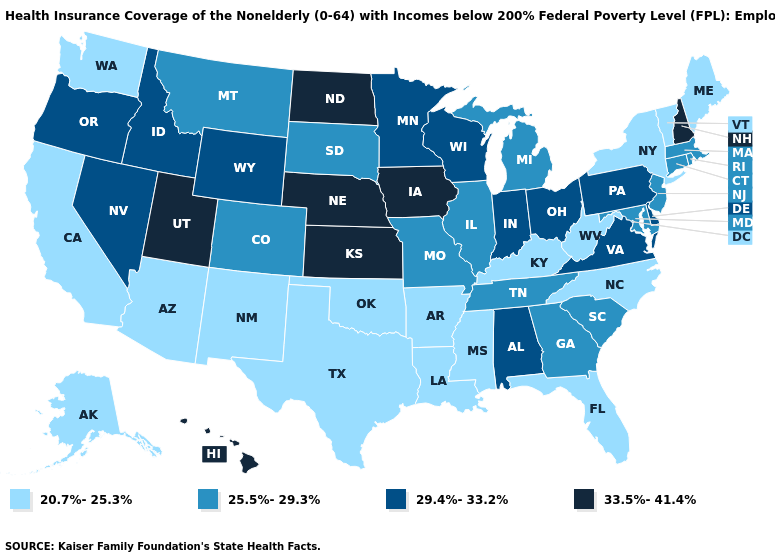What is the value of Pennsylvania?
Keep it brief. 29.4%-33.2%. What is the value of Rhode Island?
Answer briefly. 25.5%-29.3%. What is the value of Alaska?
Answer briefly. 20.7%-25.3%. What is the value of Alabama?
Short answer required. 29.4%-33.2%. What is the highest value in states that border Maine?
Be succinct. 33.5%-41.4%. Which states have the highest value in the USA?
Answer briefly. Hawaii, Iowa, Kansas, Nebraska, New Hampshire, North Dakota, Utah. Which states have the lowest value in the USA?
Short answer required. Alaska, Arizona, Arkansas, California, Florida, Kentucky, Louisiana, Maine, Mississippi, New Mexico, New York, North Carolina, Oklahoma, Texas, Vermont, Washington, West Virginia. Name the states that have a value in the range 20.7%-25.3%?
Short answer required. Alaska, Arizona, Arkansas, California, Florida, Kentucky, Louisiana, Maine, Mississippi, New Mexico, New York, North Carolina, Oklahoma, Texas, Vermont, Washington, West Virginia. Which states have the lowest value in the Northeast?
Concise answer only. Maine, New York, Vermont. What is the value of Illinois?
Write a very short answer. 25.5%-29.3%. Does Wyoming have a lower value than Alaska?
Short answer required. No. Among the states that border North Carolina , does Virginia have the highest value?
Quick response, please. Yes. Which states have the lowest value in the West?
Quick response, please. Alaska, Arizona, California, New Mexico, Washington. Which states have the highest value in the USA?
Quick response, please. Hawaii, Iowa, Kansas, Nebraska, New Hampshire, North Dakota, Utah. What is the lowest value in states that border Oregon?
Write a very short answer. 20.7%-25.3%. 